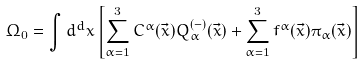Convert formula to latex. <formula><loc_0><loc_0><loc_500><loc_500>\Omega _ { 0 } = \int d ^ { d } x \left [ \sum _ { \alpha = 1 } ^ { 3 } C ^ { \alpha } ( \vec { x } ) Q ^ { ( - ) } _ { \alpha } ( \vec { x } ) + \sum _ { \alpha = 1 } ^ { 3 } f ^ { \alpha } ( \vec { x } ) \pi _ { \alpha } ( \vec { x } ) \right ]</formula> 